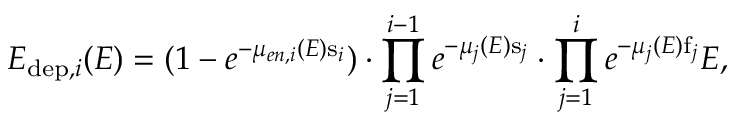<formula> <loc_0><loc_0><loc_500><loc_500>E _ { d e p , i } ( E ) = ( 1 - e ^ { - \mu _ { e n , i } ( E ) s _ { i } } ) \cdot \prod _ { j = 1 } ^ { i - 1 } e ^ { - \mu _ { j } ( E ) s _ { j } } \cdot \prod _ { j = 1 } ^ { i } e ^ { - \mu _ { j } ( E ) f _ { j } } E ,</formula> 